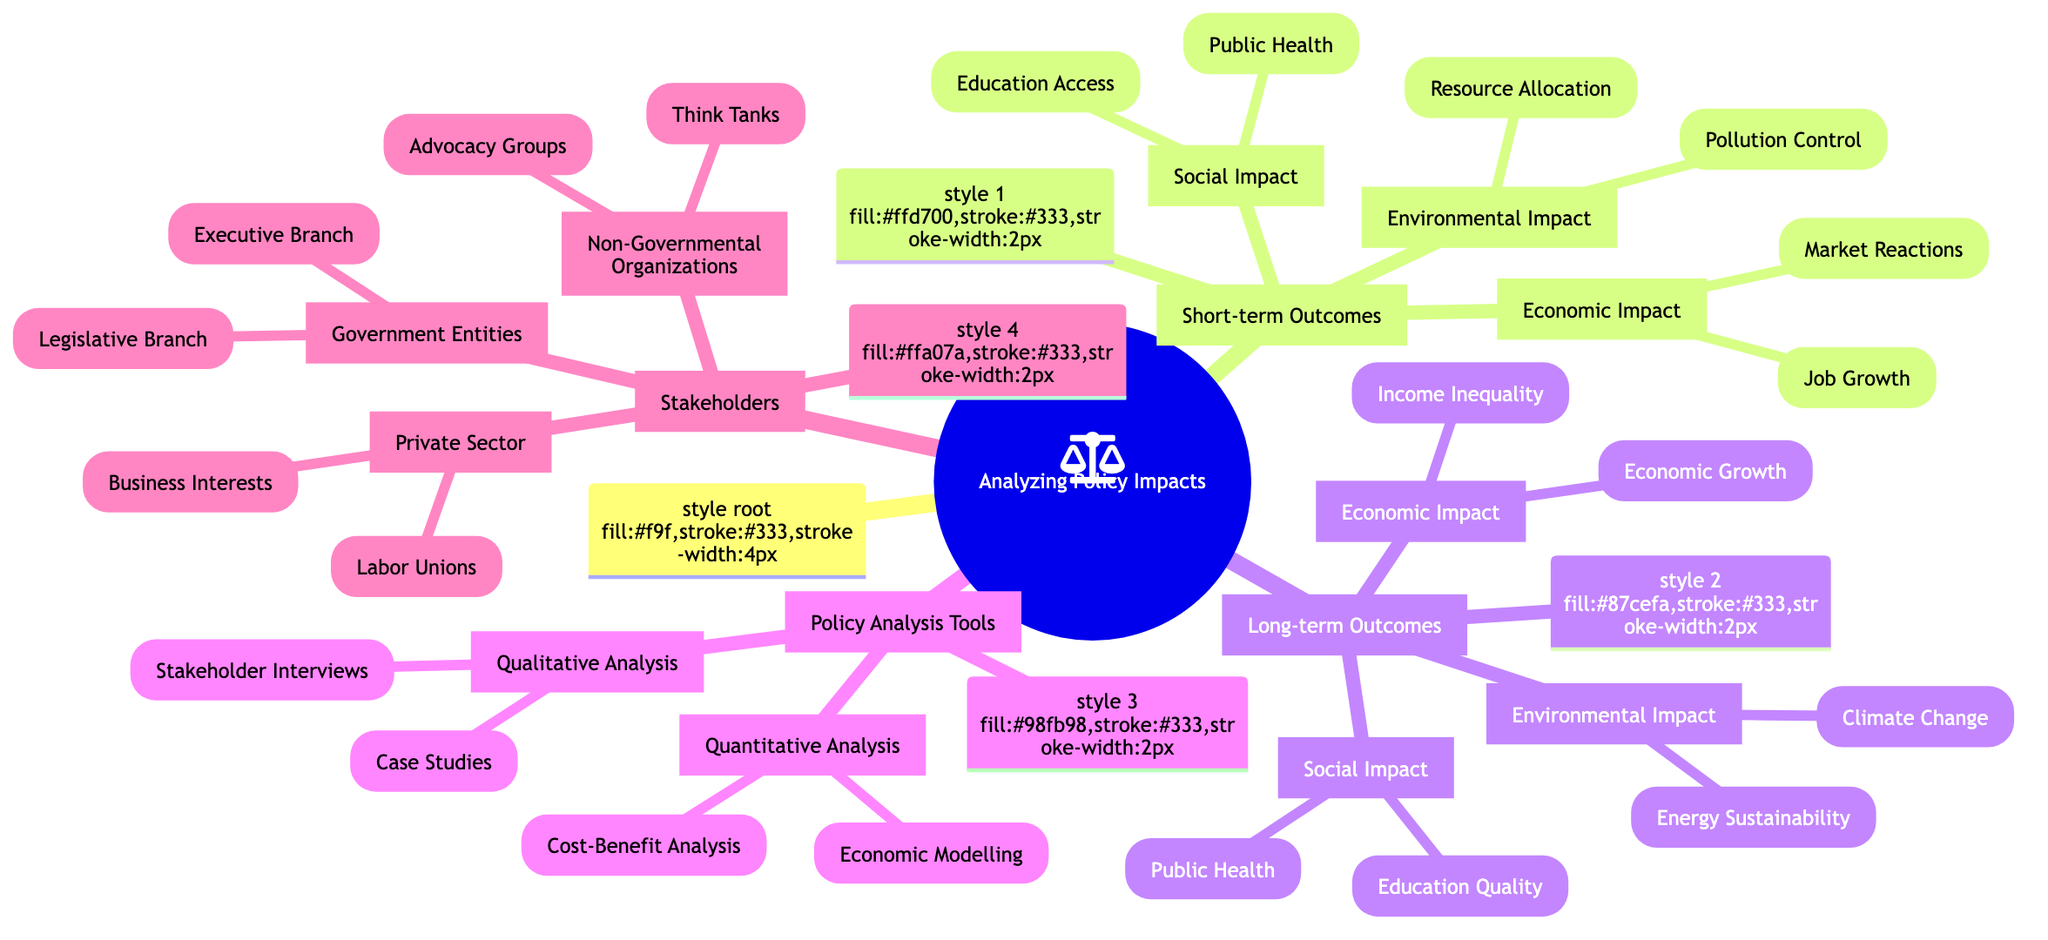What are the three main categories of short-term outcomes? In the diagram, the main categories under short-term outcomes are labeled clearly as Economic Impact, Social Impact, and Environmental Impact.
Answer: Economic Impact, Social Impact, Environmental Impact Which act is associated with job growth in the short-term outcomes? The diagram specifies that "The American Recovery and Reinvestment Act" is directly linked to the node labeled Job Growth, indicating its relevance to short-term economic outcomes.
Answer: The American Recovery and Reinvestment Act What long-term outcome addresses income inequality? The diagram indicates that "Social Security Act" is connected to the Income Inequality node under Long-term Outcomes, thus highlighting its significance in addressing this issue.
Answer: Social Security Act How many types of analysis tools are listed in the diagram? The mind map shows two main categories under Policy Analysis Tools: Quantitative Analysis and Qualitative Analysis. Therefore, the total number of analysis types listed amounts to two.
Answer: Two Which agreement relates to climate change in long-term outcomes? The diagram highlights "Paris Agreement" under the Climate Change node, signaling its role in addressing climate change in long-term outcomes.
Answer: Paris Agreement What type of organization is represented by the Chamber of Commerce? According to the diagram, the Chamber of Commerce is categorized under the Private Sector, indicating its classification as a business interest organization.
Answer: Private Sector Name one qualitative analysis method shown in the diagram. The mind map provides "Stakeholder Interviews" as one of the qualitative analysis methods under the Qualitative Analysis category, making it an example of a qualitative tool.
Answer: Stakeholder Interviews Which two entities are listed under Government Entities? The diagram mentions Legislative Branch and Executive Branch as the two entities categorized under Government Entities, summarizing their roles in the context of policy analysis.
Answer: Legislative Branch, Executive Branch What is associated with education quality in long-term outcomes? Based on the information in the diagram, "Higher Education Act" is specifically linked to the education quality node, indicating its importance in improving educational standards in the long-term.
Answer: Higher Education Act 